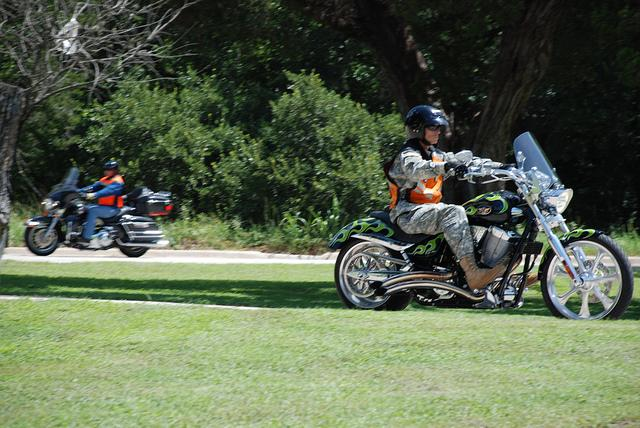The man riding the motorcycle is involved in what type of public service? military 